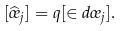Convert formula to latex. <formula><loc_0><loc_0><loc_500><loc_500>[ \widehat { \sigma } _ { j } ] = q [ \in d \sigma _ { j } ] .</formula> 